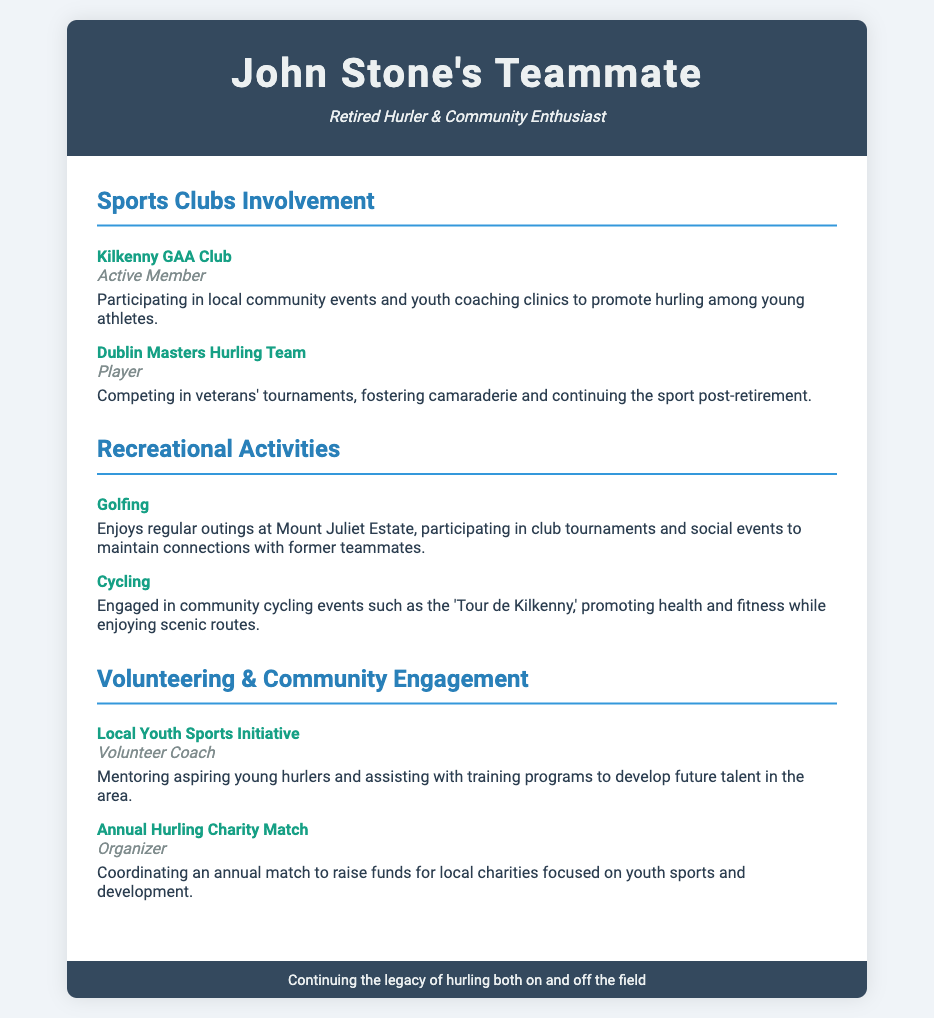what is the name of the first sports club mentioned? The first sports club listed in the document is the Kilkenny GAA Club.
Answer: Kilkenny GAA Club what role does John Stone have in the Dublin Masters Hurling Team? John Stone is listed as a Player in the Dublin Masters Hurling Team.
Answer: Player what recreational activity does John Stone enjoy that involves competitions? John Stone enjoys golfing and participates in club tournaments.
Answer: Golfing which cycling event does John Stone participate in? The document mentions his involvement in the 'Tour de Kilkenny' cycling event.
Answer: Tour de Kilkenny how does John Stone contribute to local youth sports? He mentors young hurlers as a Volunteer Coach in the Local Youth Sports Initiative.
Answer: Volunteer Coach what type of event does John Stone organize annually? He coordinates an Annual Hurling Charity Match.
Answer: Annual Hurling Charity Match what are the two main categories of involvement listed in the document? The main categories are Sports Clubs Involvement and Recreational Activities.
Answer: Sports Clubs Involvement and Recreational Activities what is the purpose of the Annual Hurling Charity Match? The match aims to raise funds for local charities focused on youth sports and development.
Answer: Raise funds for local charities how does John Stone maintain connections with former teammates? He maintains connections through golfing outings and social events.
Answer: Golfing outings and social events 